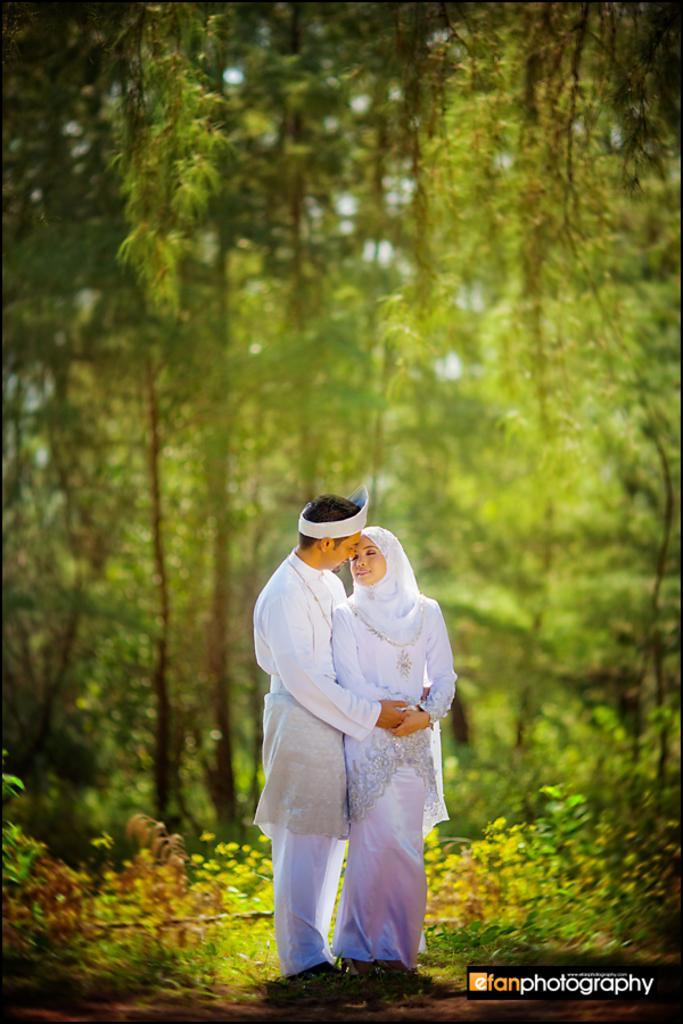Please provide a concise description of this image. In this picture I can observe a couple standing on the land. Both of them are wearing white color dresses. On the bottom right side there is a watermark. In the background there are trees and plants. 